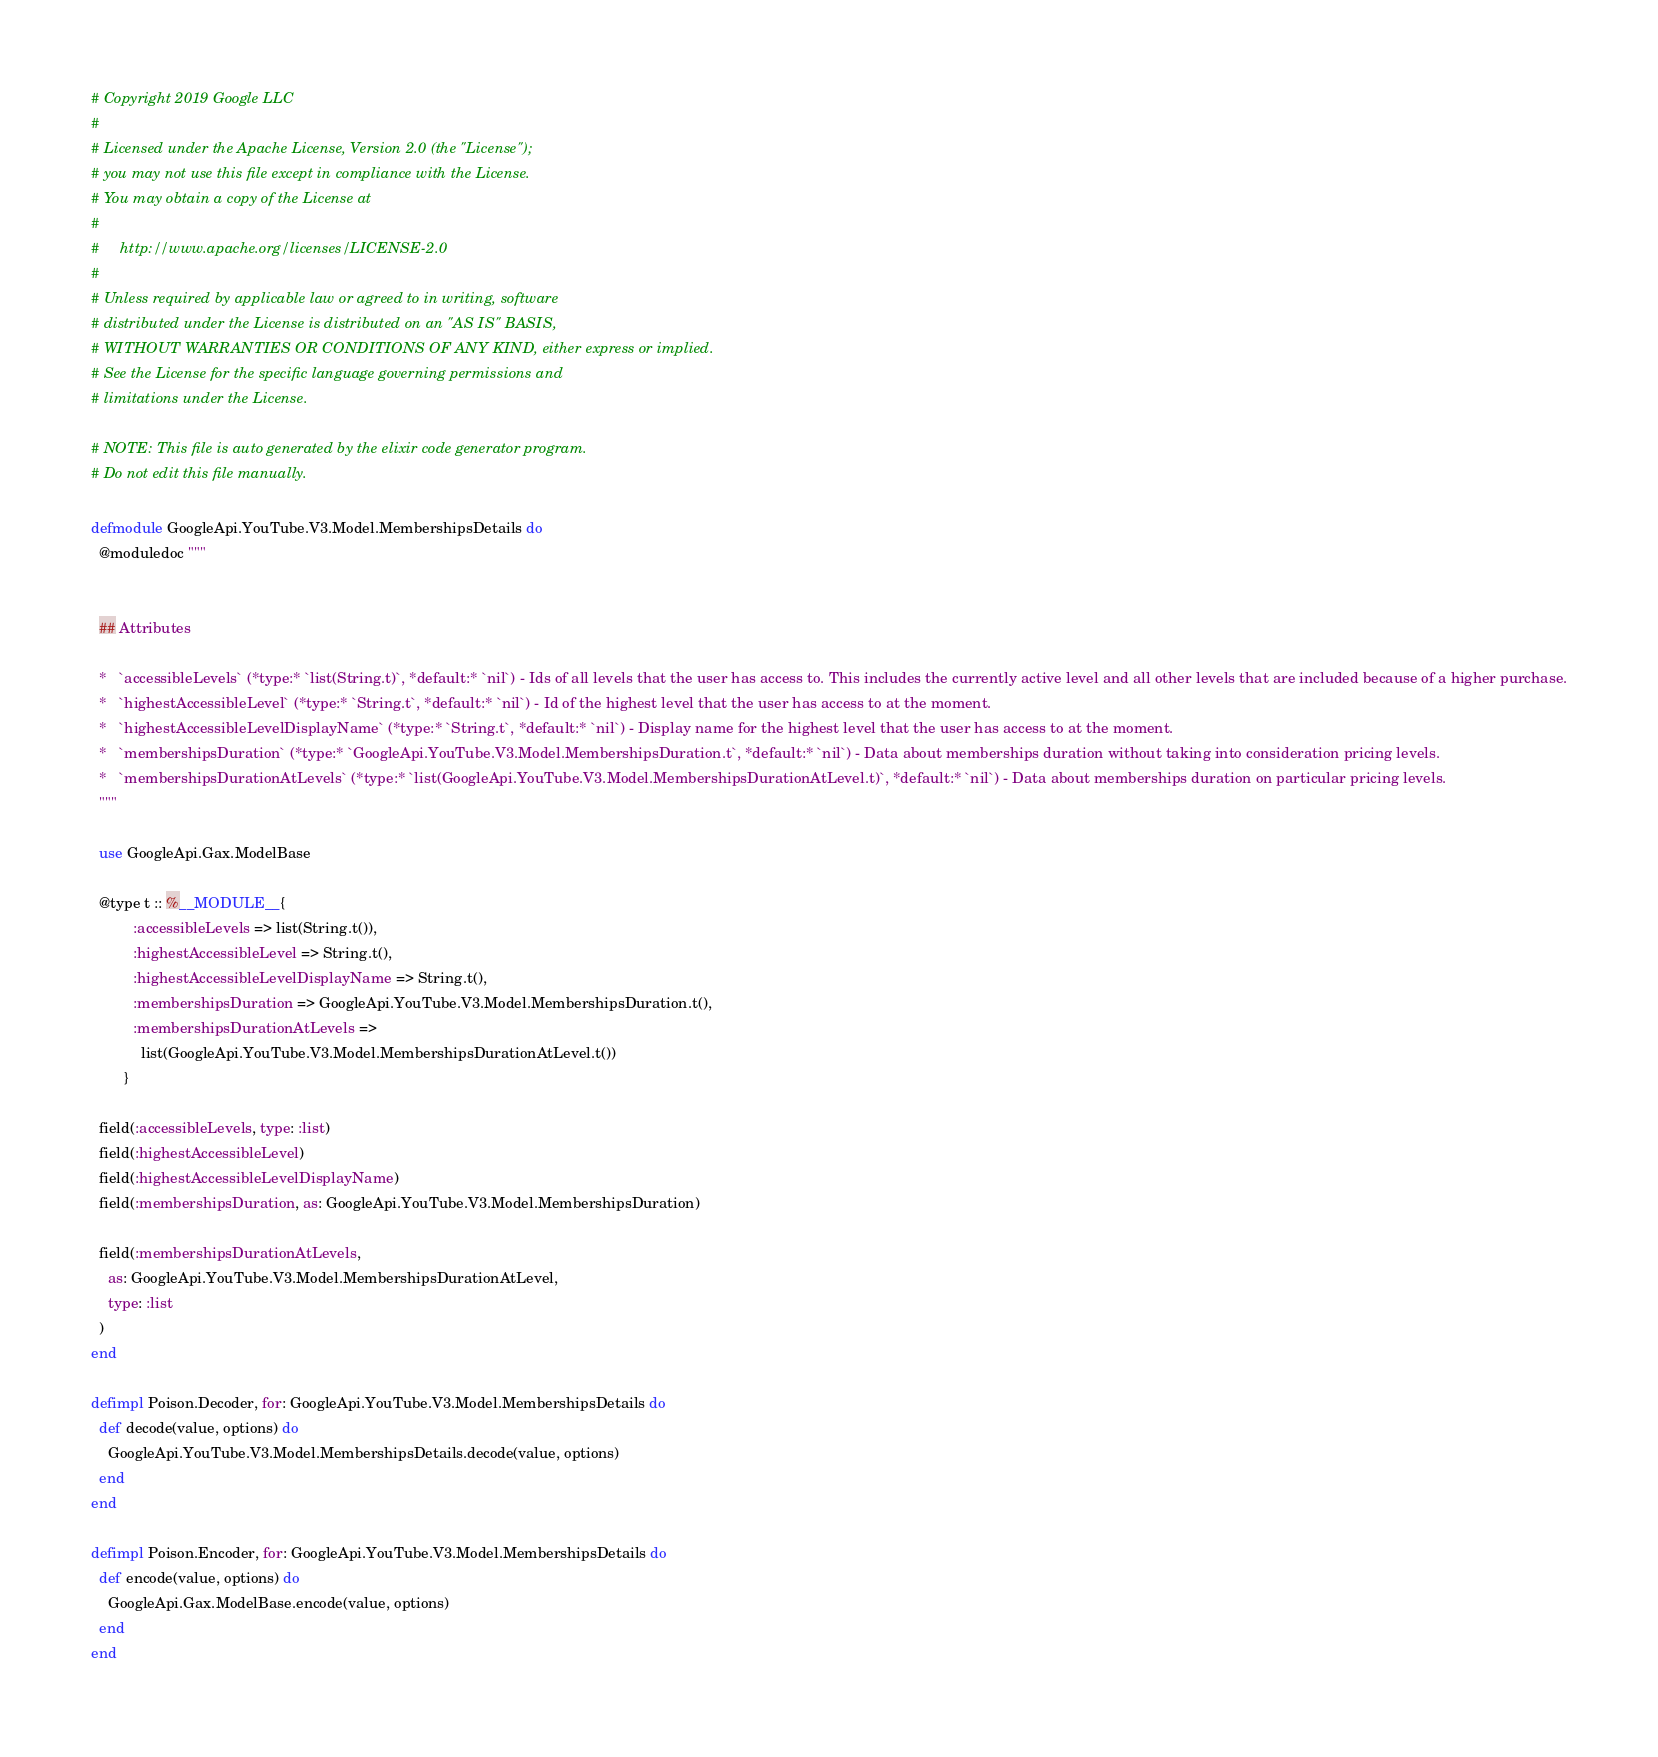<code> <loc_0><loc_0><loc_500><loc_500><_Elixir_># Copyright 2019 Google LLC
#
# Licensed under the Apache License, Version 2.0 (the "License");
# you may not use this file except in compliance with the License.
# You may obtain a copy of the License at
#
#     http://www.apache.org/licenses/LICENSE-2.0
#
# Unless required by applicable law or agreed to in writing, software
# distributed under the License is distributed on an "AS IS" BASIS,
# WITHOUT WARRANTIES OR CONDITIONS OF ANY KIND, either express or implied.
# See the License for the specific language governing permissions and
# limitations under the License.

# NOTE: This file is auto generated by the elixir code generator program.
# Do not edit this file manually.

defmodule GoogleApi.YouTube.V3.Model.MembershipsDetails do
  @moduledoc """


  ## Attributes

  *   `accessibleLevels` (*type:* `list(String.t)`, *default:* `nil`) - Ids of all levels that the user has access to. This includes the currently active level and all other levels that are included because of a higher purchase.
  *   `highestAccessibleLevel` (*type:* `String.t`, *default:* `nil`) - Id of the highest level that the user has access to at the moment.
  *   `highestAccessibleLevelDisplayName` (*type:* `String.t`, *default:* `nil`) - Display name for the highest level that the user has access to at the moment.
  *   `membershipsDuration` (*type:* `GoogleApi.YouTube.V3.Model.MembershipsDuration.t`, *default:* `nil`) - Data about memberships duration without taking into consideration pricing levels.
  *   `membershipsDurationAtLevels` (*type:* `list(GoogleApi.YouTube.V3.Model.MembershipsDurationAtLevel.t)`, *default:* `nil`) - Data about memberships duration on particular pricing levels.
  """

  use GoogleApi.Gax.ModelBase

  @type t :: %__MODULE__{
          :accessibleLevels => list(String.t()),
          :highestAccessibleLevel => String.t(),
          :highestAccessibleLevelDisplayName => String.t(),
          :membershipsDuration => GoogleApi.YouTube.V3.Model.MembershipsDuration.t(),
          :membershipsDurationAtLevels =>
            list(GoogleApi.YouTube.V3.Model.MembershipsDurationAtLevel.t())
        }

  field(:accessibleLevels, type: :list)
  field(:highestAccessibleLevel)
  field(:highestAccessibleLevelDisplayName)
  field(:membershipsDuration, as: GoogleApi.YouTube.V3.Model.MembershipsDuration)

  field(:membershipsDurationAtLevels,
    as: GoogleApi.YouTube.V3.Model.MembershipsDurationAtLevel,
    type: :list
  )
end

defimpl Poison.Decoder, for: GoogleApi.YouTube.V3.Model.MembershipsDetails do
  def decode(value, options) do
    GoogleApi.YouTube.V3.Model.MembershipsDetails.decode(value, options)
  end
end

defimpl Poison.Encoder, for: GoogleApi.YouTube.V3.Model.MembershipsDetails do
  def encode(value, options) do
    GoogleApi.Gax.ModelBase.encode(value, options)
  end
end
</code> 